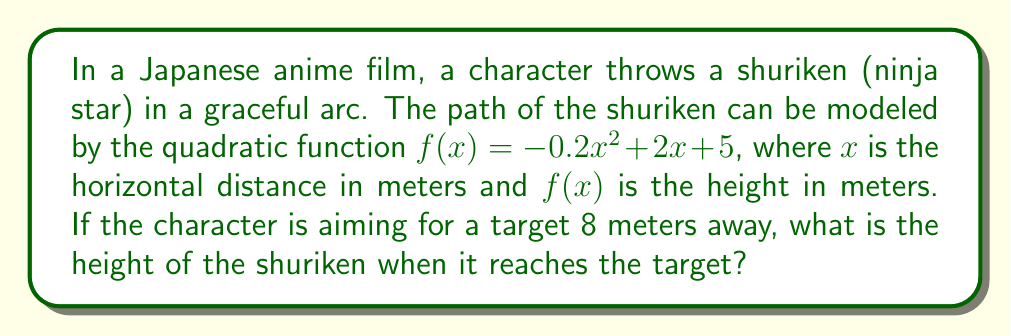Help me with this question. To solve this problem, we need to follow these steps:

1) We are given the quadratic function $f(x) = -0.2x^2 + 2x + 5$

2) We need to find the height when $x = 8$ (as the target is 8 meters away)

3) To do this, we simply substitute $x = 8$ into our function:

   $f(8) = -0.2(8)^2 + 2(8) + 5$

4) Let's calculate this step by step:
   
   $f(8) = -0.2(64) + 16 + 5$
   
   $f(8) = -12.8 + 16 + 5$
   
   $f(8) = 3.2 + 5$
   
   $f(8) = 8.2$

5) Therefore, when the shuriken reaches the target 8 meters away, it will be at a height of 8.2 meters.

This problem demonstrates how quadratic functions can be used to model the trajectory of animated objects, in this case, a shuriken in a Japanese anime film. The parabolic path of the shuriken is a common feature in many animation styles, particularly in action scenes.
Answer: The height of the shuriken when it reaches the target 8 meters away is 8.2 meters. 